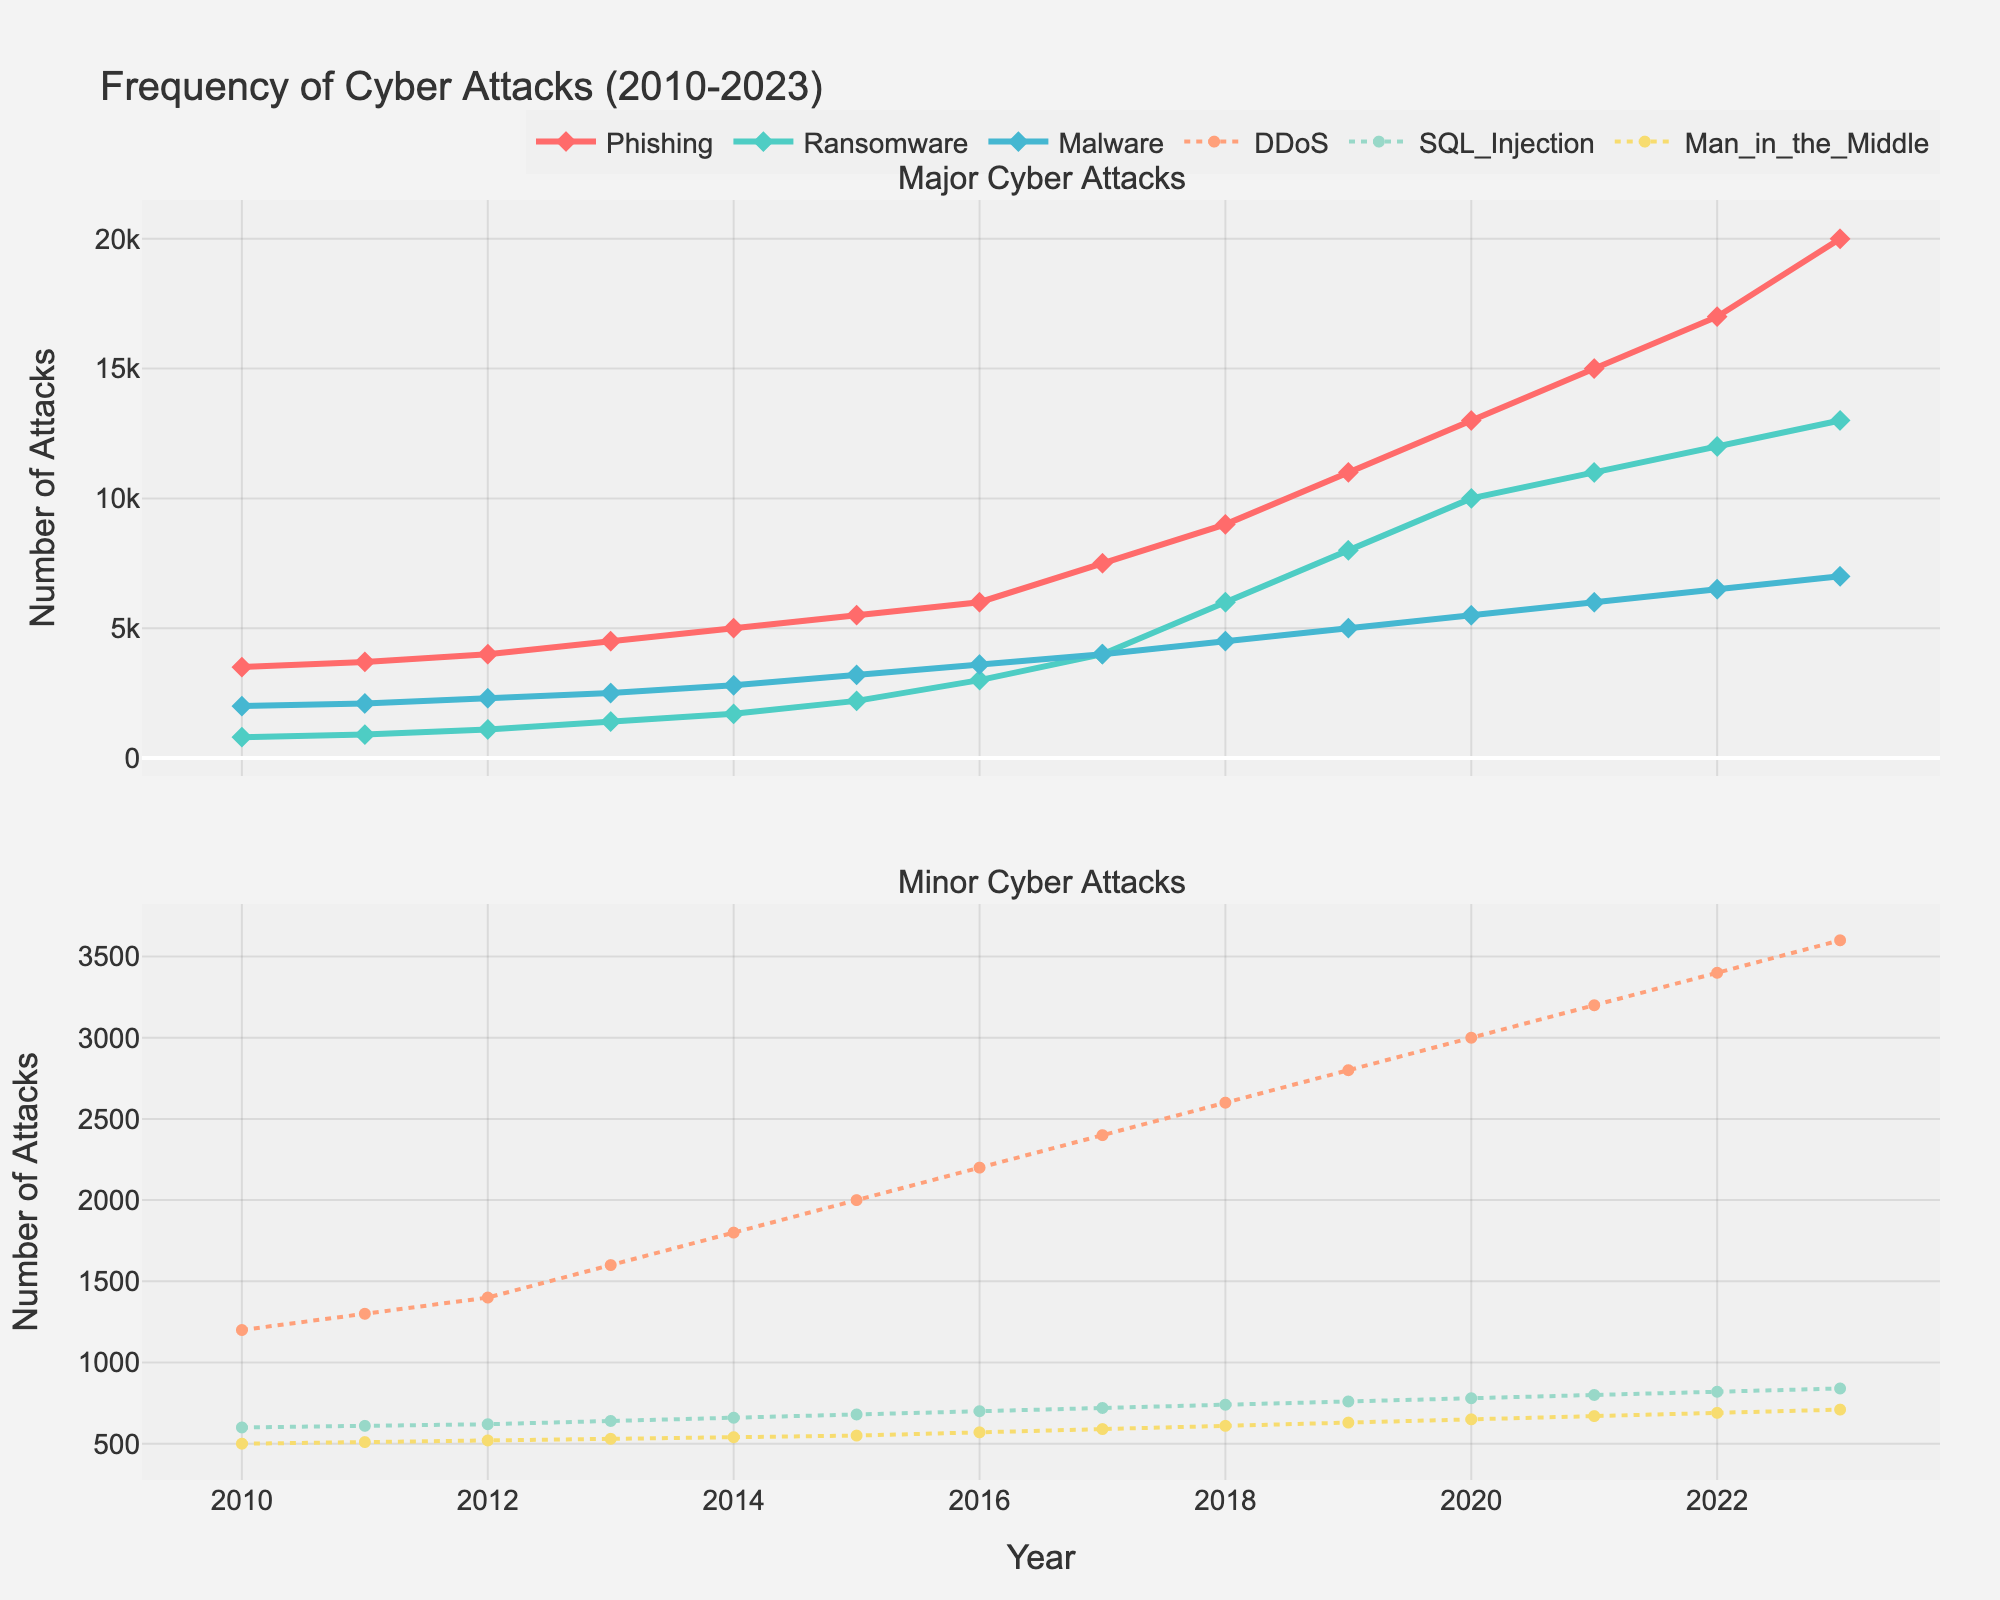What is the general trend observed for Phishing attacks from 2010 to 2023? The plot shows that the number of Phishing attacks has been increasing steadily over the years, starting at 3500 in 2010 and rising to 20000 in 2023.
Answer: Increasing Which cyber attack type had the highest frequency in 2023? In 2023, Phishing attacks had the highest frequency, with 20000 reports.
Answer: Phishing Compare the number of Ransomware attacks to Malware attacks in 2021. Which was higher and by how much? In 2021, the number of Ransomware attacks was 11000, while Malware attacks were 6000. Ransomware attacks were higher by 5000.
Answer: Ransomware by 5000 In which year did Phishing attacks surpass 10000 for the first time? The plot shows that Phishing attacks first surpassed 10000 in the year 2019.
Answer: 2019 What is the difference in the number of DDoS attacks between 2010 and 2023? In 2010, the number of DDoS attacks was 1200, and in 2023 it was 3600. Therefore, the difference is 3600 - 1200 = 2400.
Answer: 2400 How do the trends of SQL Injection and Man-in-the-Middle attacks from 2010 to 2023 compare? Both SQL Injection and Man-in-the-Middle attacks show a steady increase over the years, but SQL Injection increased from 600 to 840 while Man-in-the-Middle increased from 500 to 710.
Answer: Both increased steadily, SQL Injection increased more Which type of attack showed the most dramatic increase over the years? Phishing attacks showed the most dramatic increase, rising from 3500 in 2010 to 20000 in 2023.
Answer: Phishing Calculate the average annual increase in Ransomware attacks from 2010 to 2023. The total increase in Ransomware attacks from 2010 (800) to 2023 (13000) is 13000 - 800 = 12200. Dividing this increase by the 13 years gives an average annual increase of 12200 / 13 ≈ 938.46.
Answer: ≈ 938.46 Which cyber attack type showed a consistent yearly increase without any decline? Phishing attacks showed a consistent increase each year from 2010 to 2023 without any decline.
Answer: Phishing 